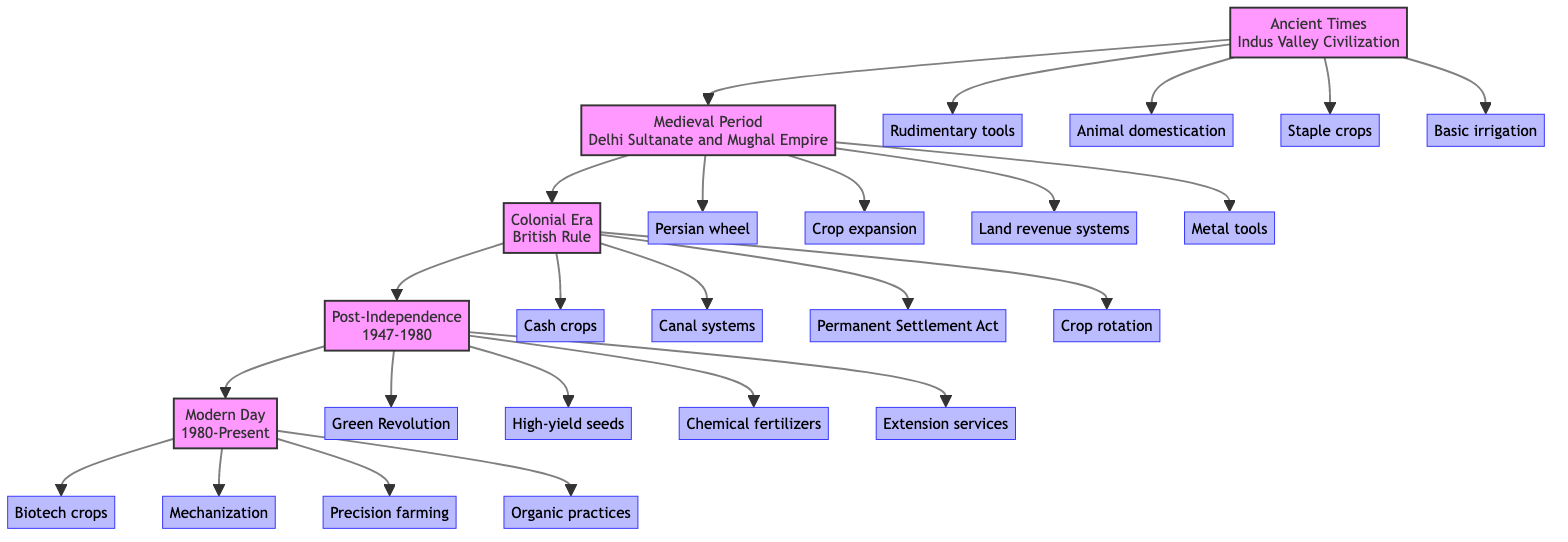What period does the block labeled "C" represent? The block labeled "C" corresponds to the "Colonial Era" with the description "British Rule". This is found directly on the diagram as the third chronological block.
Answer: Colonial Era How many key elements are listed under "Medieval Period"? The "Medieval Period" block contains four key elements: Persian wheel, crop expansion, land revenue systems, and metal tools. This can be counted in the diagram below block "B".
Answer: 4 Which irrigation system was introduced in the "Medieval Period"? The introduction of the Persian wheel for irrigation is the primary innovation mentioned under the "Medieval Period" block. It is highlighted directly in the key elements of that section.
Answer: Persian wheel What major agricultural revolution occurred in Bulandshahr from 1947 to 1980? The Green Revolution was the major agricultural event during this period, as stated under the "Post-Independence" block in the key elements.
Answer: Green Revolution What are two techniques introduced during the Colonial Era for improving agriculture? Under the "Colonial Era" block, two techniques introduced are the development of canal systems for irrigation and new crop rotation techniques, both listed in the key elements.
Answer: Canal systems, crop rotation What is a common theme in the "Modern Day" section regarding farming practices? The "Modern Day" section emphasizes a shift towards sustainable practices, highlighting the introduction of organic farming and precision farming. This reflects the modern focus on sustainability in agriculture.
Answer: Sustainable practices Which period in the diagram saw the introduction of metal tools? The introduction of metal tools occurred during the "Medieval Period," as indicated under block "B" in the key elements associated with that period.
Answer: Medieval Period How does agricultural practice evolve from ancient times to modern day in terms of tools used? The evolution goes from rudimentary wooden tools in "Ancient Times" to the mechanization of agriculture with tractors in the "Modern Day". This is indicated by the transition from block "A" to block "E".
Answer: From wooden tools to mechanization 